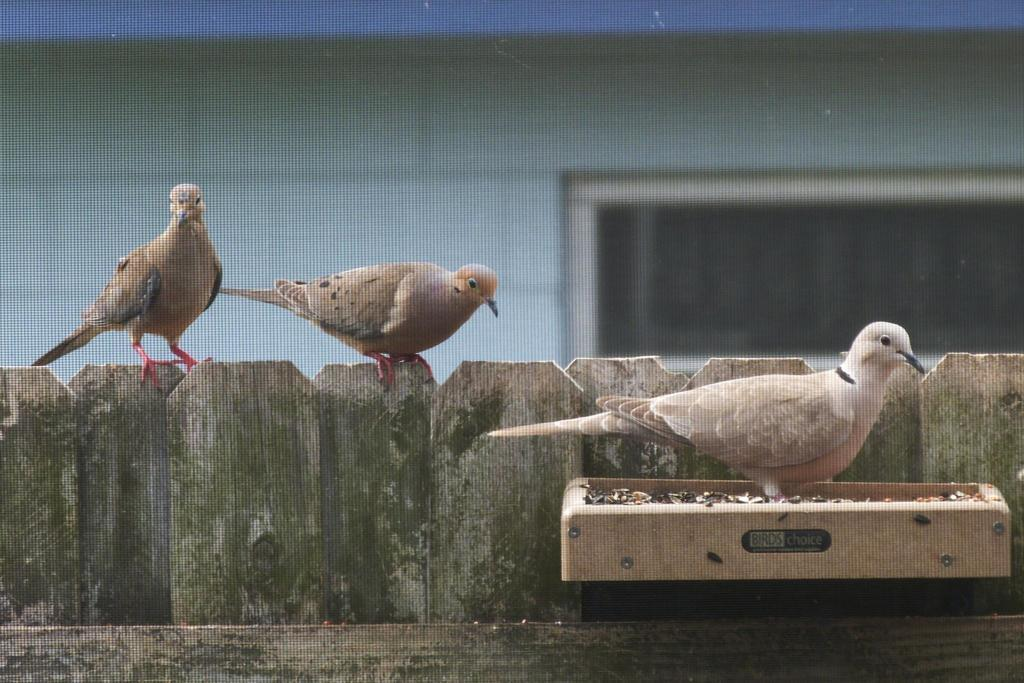How many birds are visible in the image? There are three birds in the image. Where are two of the birds located? Two birds are standing on a wooden fence. Where is the third bird located? The third bird is standing on a wooden box. What can be observed about the background of the birds? The background of the birds is blurred. What is the moon attempting to do in the image? There is no moon present in the image, so it cannot be attempting to do anything. 